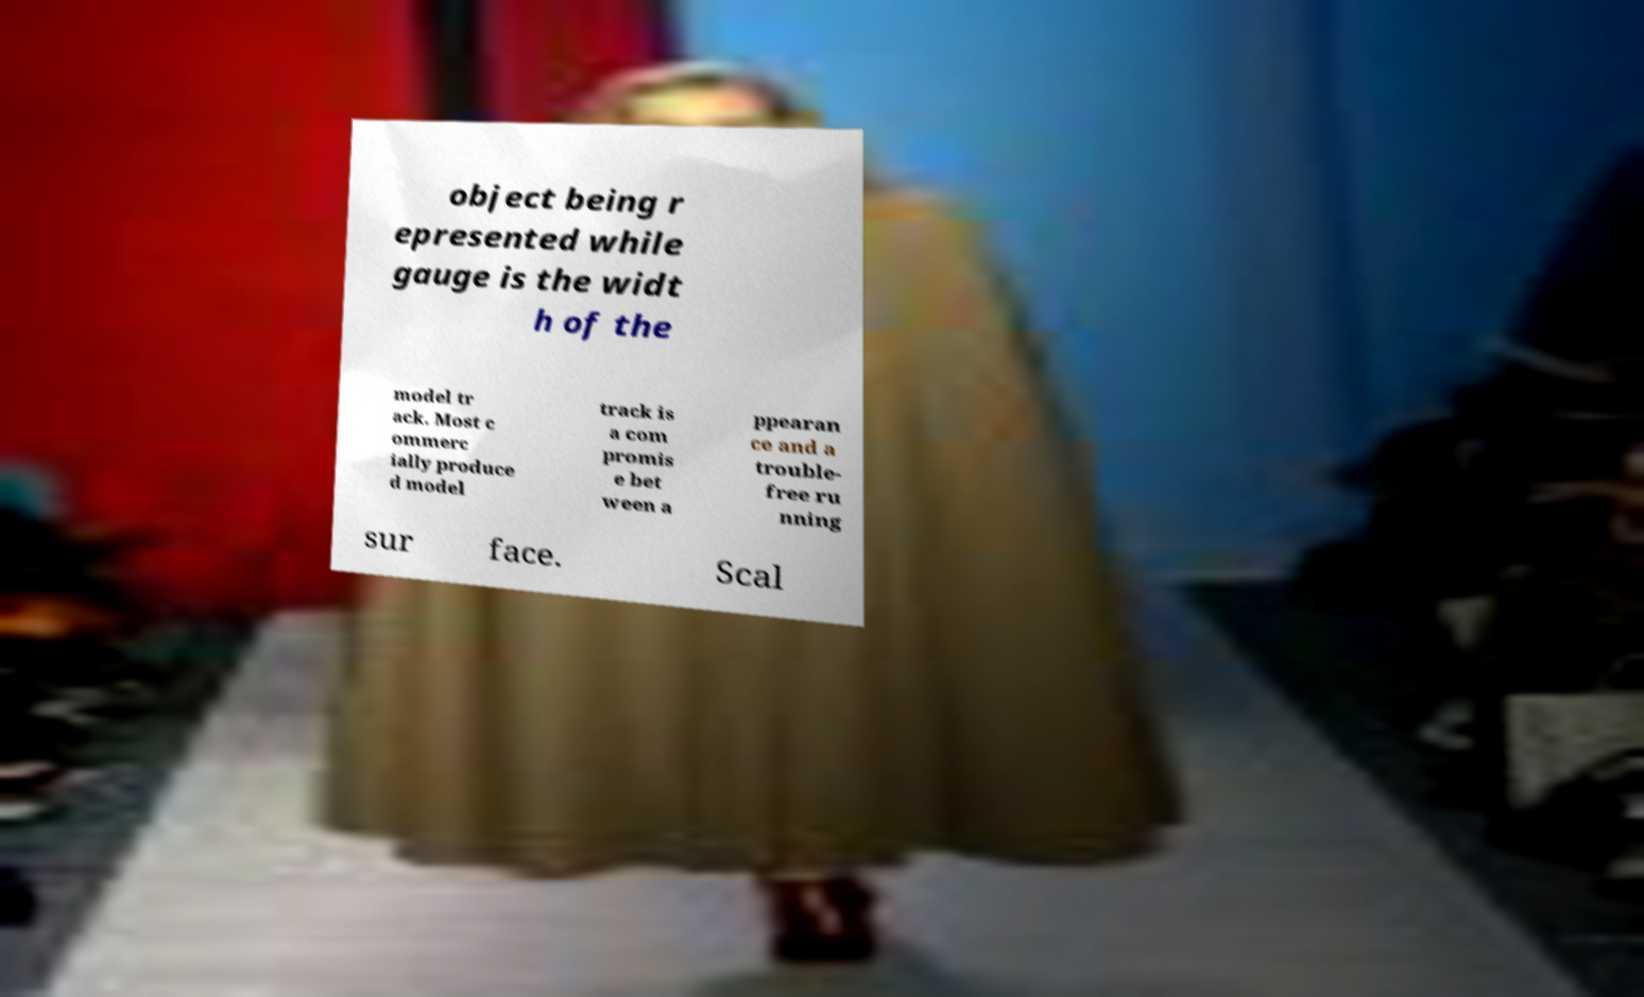Can you read and provide the text displayed in the image?This photo seems to have some interesting text. Can you extract and type it out for me? object being r epresented while gauge is the widt h of the model tr ack. Most c ommerc ially produce d model track is a com promis e bet ween a ppearan ce and a trouble- free ru nning sur face. Scal 